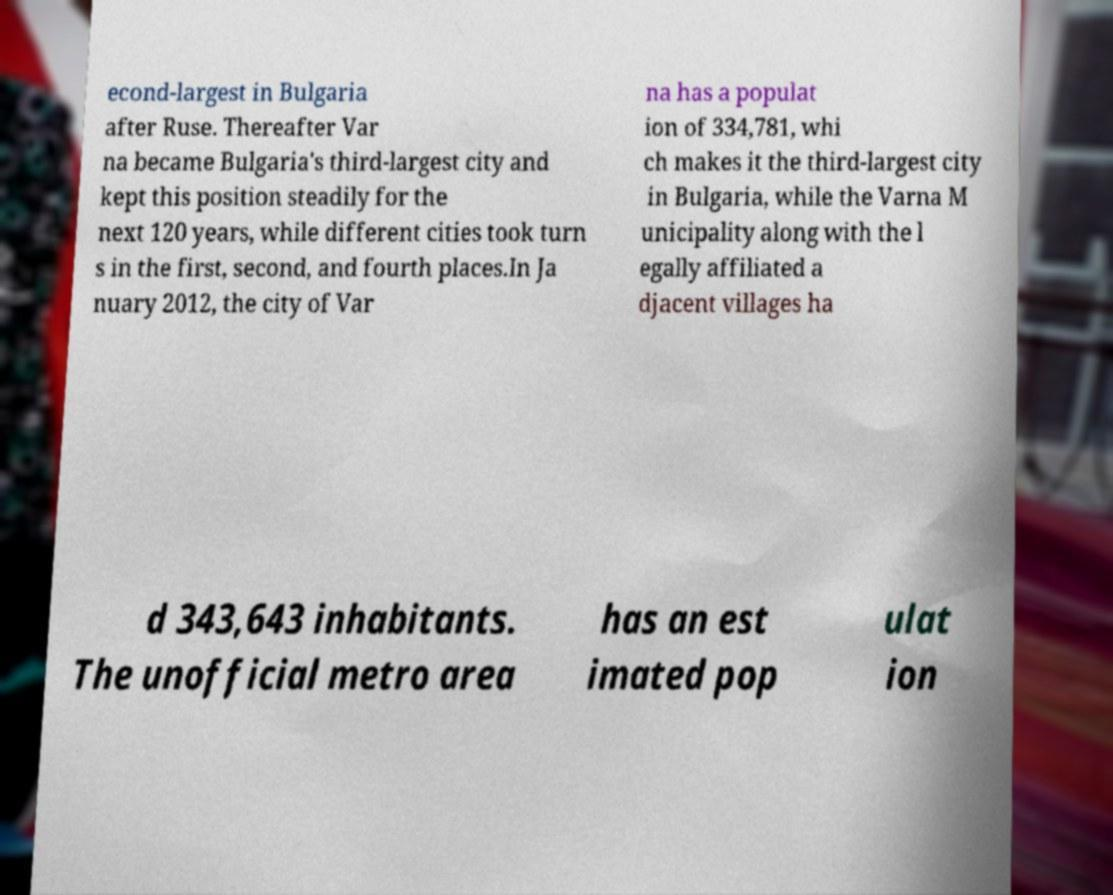There's text embedded in this image that I need extracted. Can you transcribe it verbatim? econd-largest in Bulgaria after Ruse. Thereafter Var na became Bulgaria's third-largest city and kept this position steadily for the next 120 years, while different cities took turn s in the first, second, and fourth places.In Ja nuary 2012, the city of Var na has a populat ion of 334,781, whi ch makes it the third-largest city in Bulgaria, while the Varna M unicipality along with the l egally affiliated a djacent villages ha d 343,643 inhabitants. The unofficial metro area has an est imated pop ulat ion 